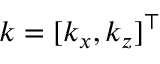Convert formula to latex. <formula><loc_0><loc_0><loc_500><loc_500>k = [ k _ { x } , k _ { z } ] ^ { \top }</formula> 